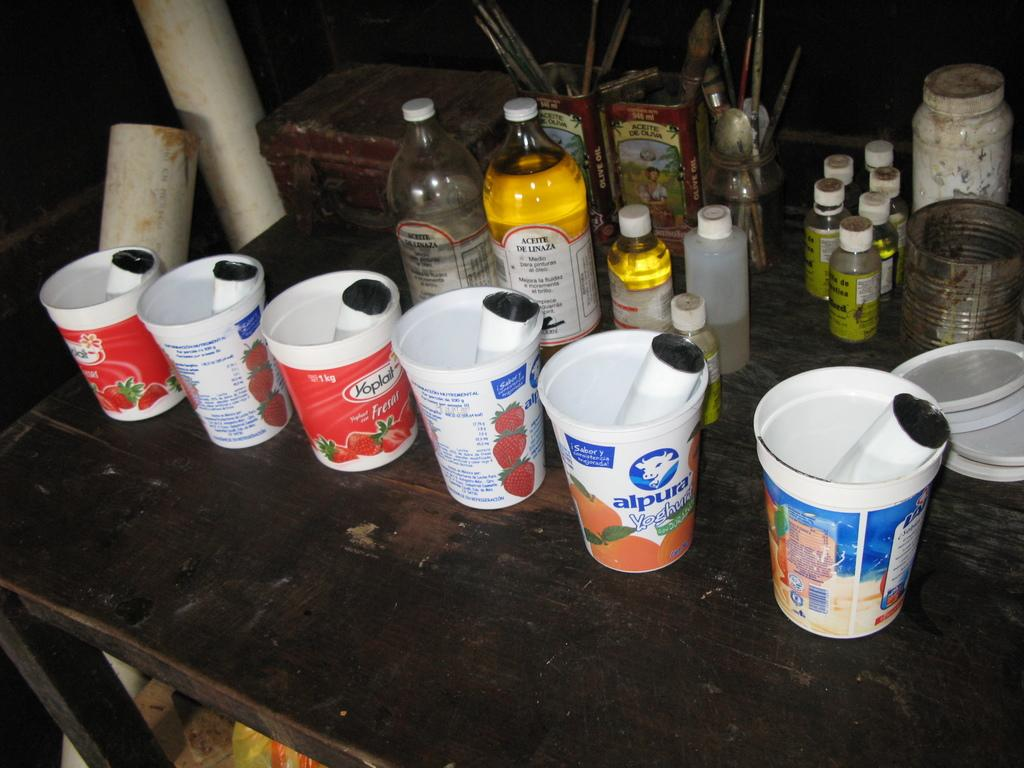<image>
Describe the image concisely. Containers of Yoplait and Alpura brand yogurt sit on a table in front of assorted dirty bottles. 